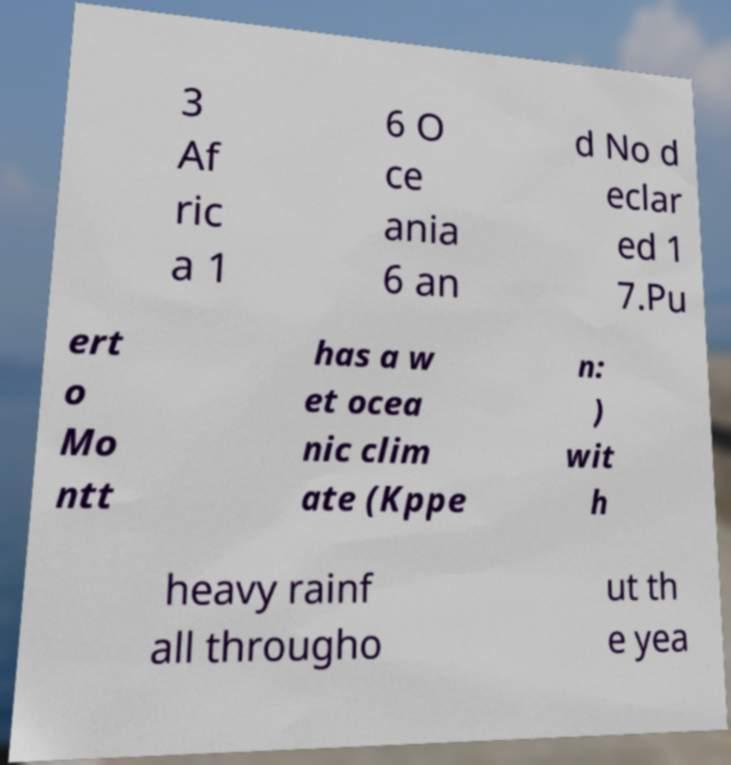Can you accurately transcribe the text from the provided image for me? 3 Af ric a 1 6 O ce ania 6 an d No d eclar ed 1 7.Pu ert o Mo ntt has a w et ocea nic clim ate (Kppe n: ) wit h heavy rainf all througho ut th e yea 